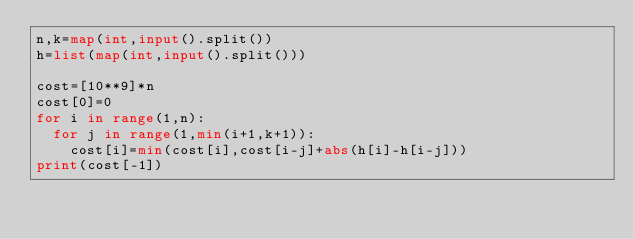<code> <loc_0><loc_0><loc_500><loc_500><_Python_>n,k=map(int,input().split())
h=list(map(int,input().split()))

cost=[10**9]*n
cost[0]=0
for i in range(1,n):
  for j in range(1,min(i+1,k+1)):
    cost[i]=min(cost[i],cost[i-j]+abs(h[i]-h[i-j]))
print(cost[-1])</code> 